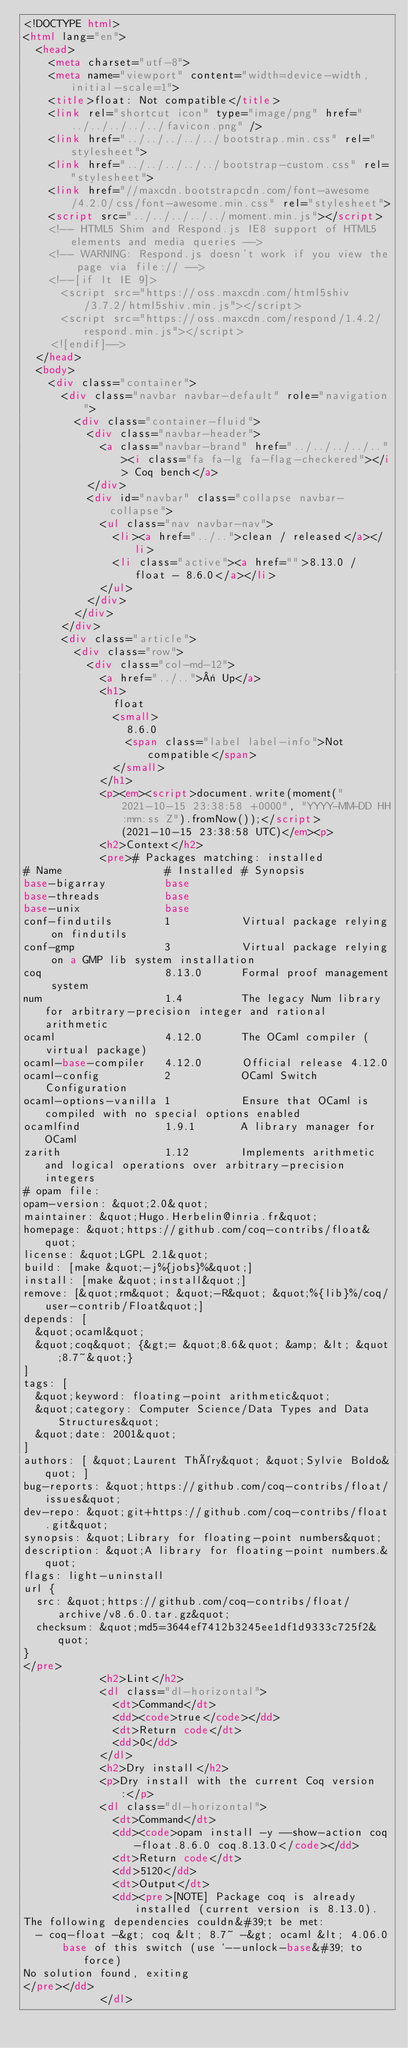Convert code to text. <code><loc_0><loc_0><loc_500><loc_500><_HTML_><!DOCTYPE html>
<html lang="en">
  <head>
    <meta charset="utf-8">
    <meta name="viewport" content="width=device-width, initial-scale=1">
    <title>float: Not compatible</title>
    <link rel="shortcut icon" type="image/png" href="../../../../../favicon.png" />
    <link href="../../../../../bootstrap.min.css" rel="stylesheet">
    <link href="../../../../../bootstrap-custom.css" rel="stylesheet">
    <link href="//maxcdn.bootstrapcdn.com/font-awesome/4.2.0/css/font-awesome.min.css" rel="stylesheet">
    <script src="../../../../../moment.min.js"></script>
    <!-- HTML5 Shim and Respond.js IE8 support of HTML5 elements and media queries -->
    <!-- WARNING: Respond.js doesn't work if you view the page via file:// -->
    <!--[if lt IE 9]>
      <script src="https://oss.maxcdn.com/html5shiv/3.7.2/html5shiv.min.js"></script>
      <script src="https://oss.maxcdn.com/respond/1.4.2/respond.min.js"></script>
    <![endif]-->
  </head>
  <body>
    <div class="container">
      <div class="navbar navbar-default" role="navigation">
        <div class="container-fluid">
          <div class="navbar-header">
            <a class="navbar-brand" href="../../../../.."><i class="fa fa-lg fa-flag-checkered"></i> Coq bench</a>
          </div>
          <div id="navbar" class="collapse navbar-collapse">
            <ul class="nav navbar-nav">
              <li><a href="../..">clean / released</a></li>
              <li class="active"><a href="">8.13.0 / float - 8.6.0</a></li>
            </ul>
          </div>
        </div>
      </div>
      <div class="article">
        <div class="row">
          <div class="col-md-12">
            <a href="../..">« Up</a>
            <h1>
              float
              <small>
                8.6.0
                <span class="label label-info">Not compatible</span>
              </small>
            </h1>
            <p><em><script>document.write(moment("2021-10-15 23:38:58 +0000", "YYYY-MM-DD HH:mm:ss Z").fromNow());</script> (2021-10-15 23:38:58 UTC)</em><p>
            <h2>Context</h2>
            <pre># Packages matching: installed
# Name                # Installed # Synopsis
base-bigarray         base
base-threads          base
base-unix             base
conf-findutils        1           Virtual package relying on findutils
conf-gmp              3           Virtual package relying on a GMP lib system installation
coq                   8.13.0      Formal proof management system
num                   1.4         The legacy Num library for arbitrary-precision integer and rational arithmetic
ocaml                 4.12.0      The OCaml compiler (virtual package)
ocaml-base-compiler   4.12.0      Official release 4.12.0
ocaml-config          2           OCaml Switch Configuration
ocaml-options-vanilla 1           Ensure that OCaml is compiled with no special options enabled
ocamlfind             1.9.1       A library manager for OCaml
zarith                1.12        Implements arithmetic and logical operations over arbitrary-precision integers
# opam file:
opam-version: &quot;2.0&quot;
maintainer: &quot;Hugo.Herbelin@inria.fr&quot;
homepage: &quot;https://github.com/coq-contribs/float&quot;
license: &quot;LGPL 2.1&quot;
build: [make &quot;-j%{jobs}%&quot;]
install: [make &quot;install&quot;]
remove: [&quot;rm&quot; &quot;-R&quot; &quot;%{lib}%/coq/user-contrib/Float&quot;]
depends: [
  &quot;ocaml&quot;
  &quot;coq&quot; {&gt;= &quot;8.6&quot; &amp; &lt; &quot;8.7~&quot;}
]
tags: [
  &quot;keyword: floating-point arithmetic&quot;
  &quot;category: Computer Science/Data Types and Data Structures&quot;
  &quot;date: 2001&quot;
]
authors: [ &quot;Laurent Théry&quot; &quot;Sylvie Boldo&quot; ]
bug-reports: &quot;https://github.com/coq-contribs/float/issues&quot;
dev-repo: &quot;git+https://github.com/coq-contribs/float.git&quot;
synopsis: &quot;Library for floating-point numbers&quot;
description: &quot;A library for floating-point numbers.&quot;
flags: light-uninstall
url {
  src: &quot;https://github.com/coq-contribs/float/archive/v8.6.0.tar.gz&quot;
  checksum: &quot;md5=3644ef7412b3245ee1df1d9333c725f2&quot;
}
</pre>
            <h2>Lint</h2>
            <dl class="dl-horizontal">
              <dt>Command</dt>
              <dd><code>true</code></dd>
              <dt>Return code</dt>
              <dd>0</dd>
            </dl>
            <h2>Dry install</h2>
            <p>Dry install with the current Coq version:</p>
            <dl class="dl-horizontal">
              <dt>Command</dt>
              <dd><code>opam install -y --show-action coq-float.8.6.0 coq.8.13.0</code></dd>
              <dt>Return code</dt>
              <dd>5120</dd>
              <dt>Output</dt>
              <dd><pre>[NOTE] Package coq is already installed (current version is 8.13.0).
The following dependencies couldn&#39;t be met:
  - coq-float -&gt; coq &lt; 8.7~ -&gt; ocaml &lt; 4.06.0
      base of this switch (use `--unlock-base&#39; to force)
No solution found, exiting
</pre></dd>
            </dl></code> 